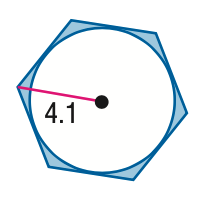Answer the mathemtical geometry problem and directly provide the correct option letter.
Question: Find the area of the shaded region. Assume that all polygons that appear to be regular are regular. Round to the nearest tenth.
Choices: A: 4.1 B: 9.1 C: 33.8 D: 36.0 A 